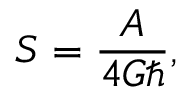<formula> <loc_0><loc_0><loc_500><loc_500>S = \frac { A } { 4 G } ,</formula> 